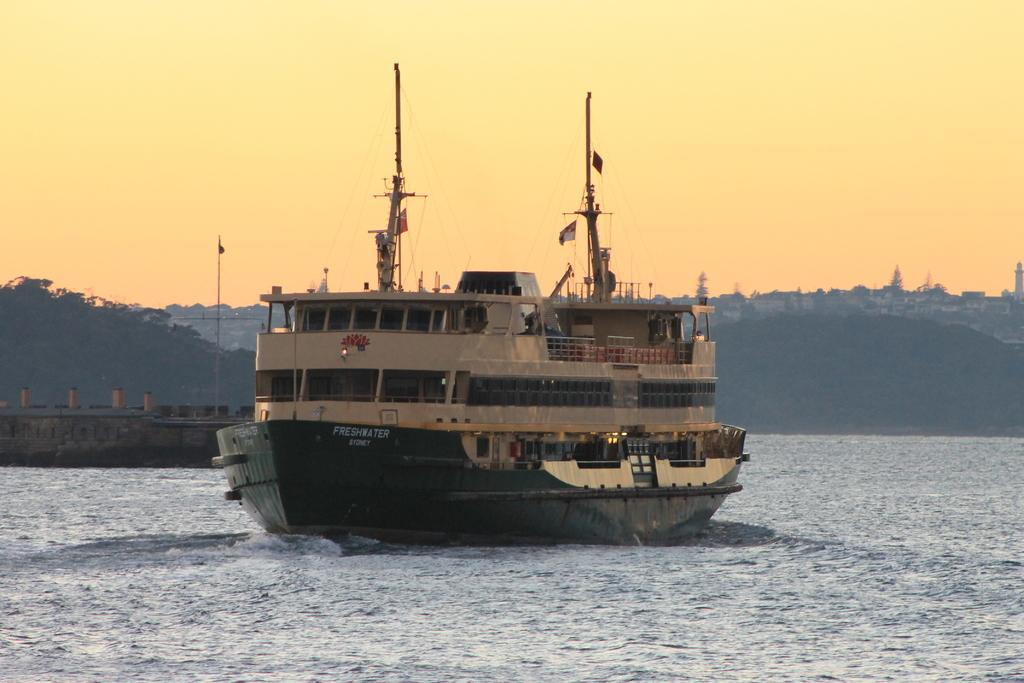What is the main subject of the image? There is a ship in the water. What can be seen in the background of the image? There are a few poles and buildings visible in the background. What type of pickle is being used to write a message on the ship's deck in the image? There is no pickle present in the image, nor is there any writing on the ship's deck. Can you see any blood stains on the ship or in the water in the image? There is no blood visible in the image. 